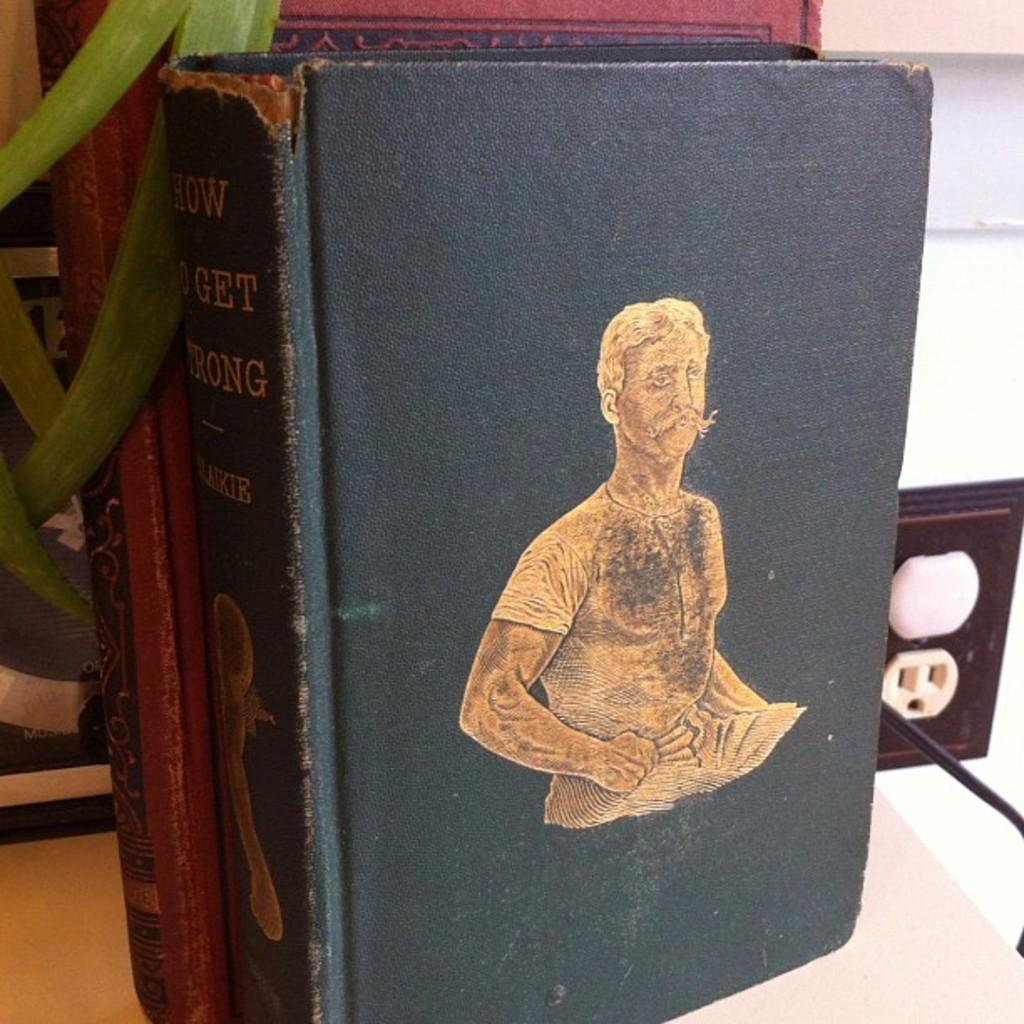<image>
Describe the image concisely. A man is pictured on a blue book cover called How to Get Strong. 